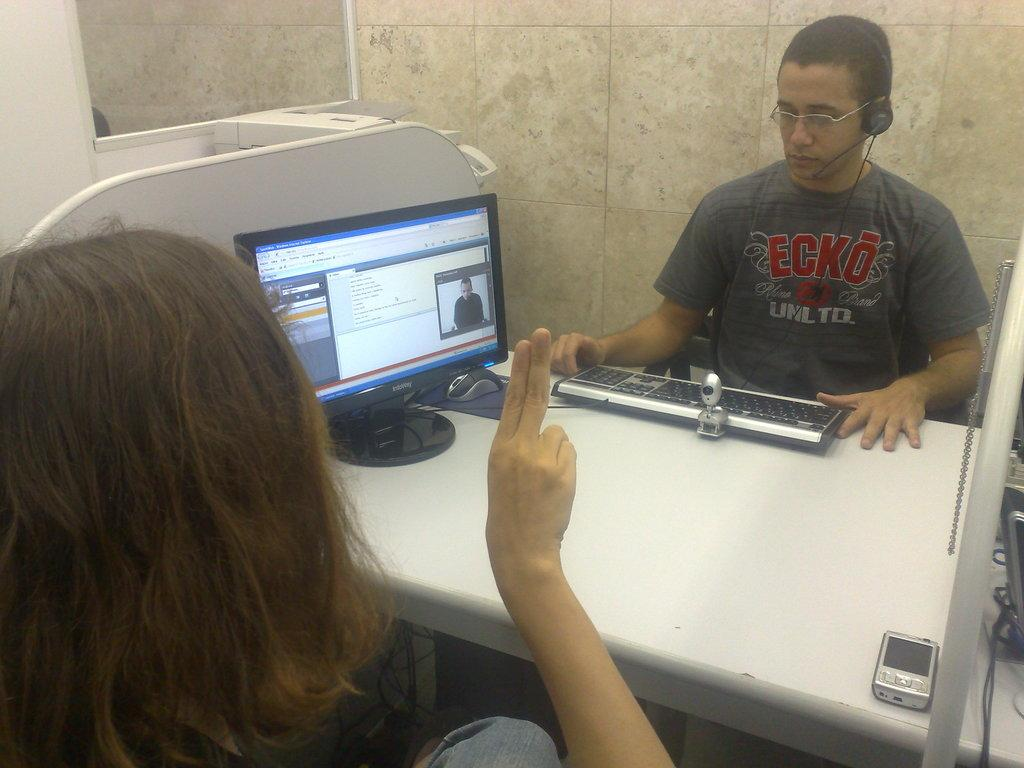<image>
Present a compact description of the photo's key features. At the desk a man wearing an Ecko Unltd t-shirt has a headset on. 